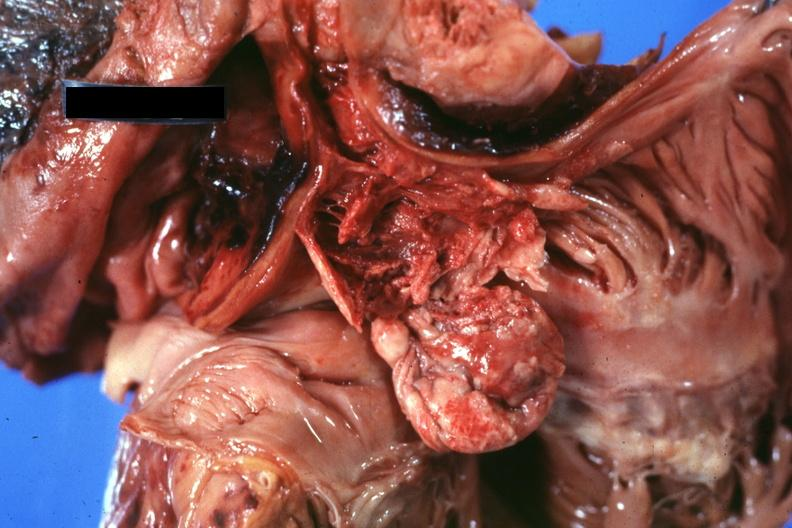does edema show opened right atrium and superior vena cava showing thrombus and tumor occlusion of cava extending into atrium?
Answer the question using a single word or phrase. No 